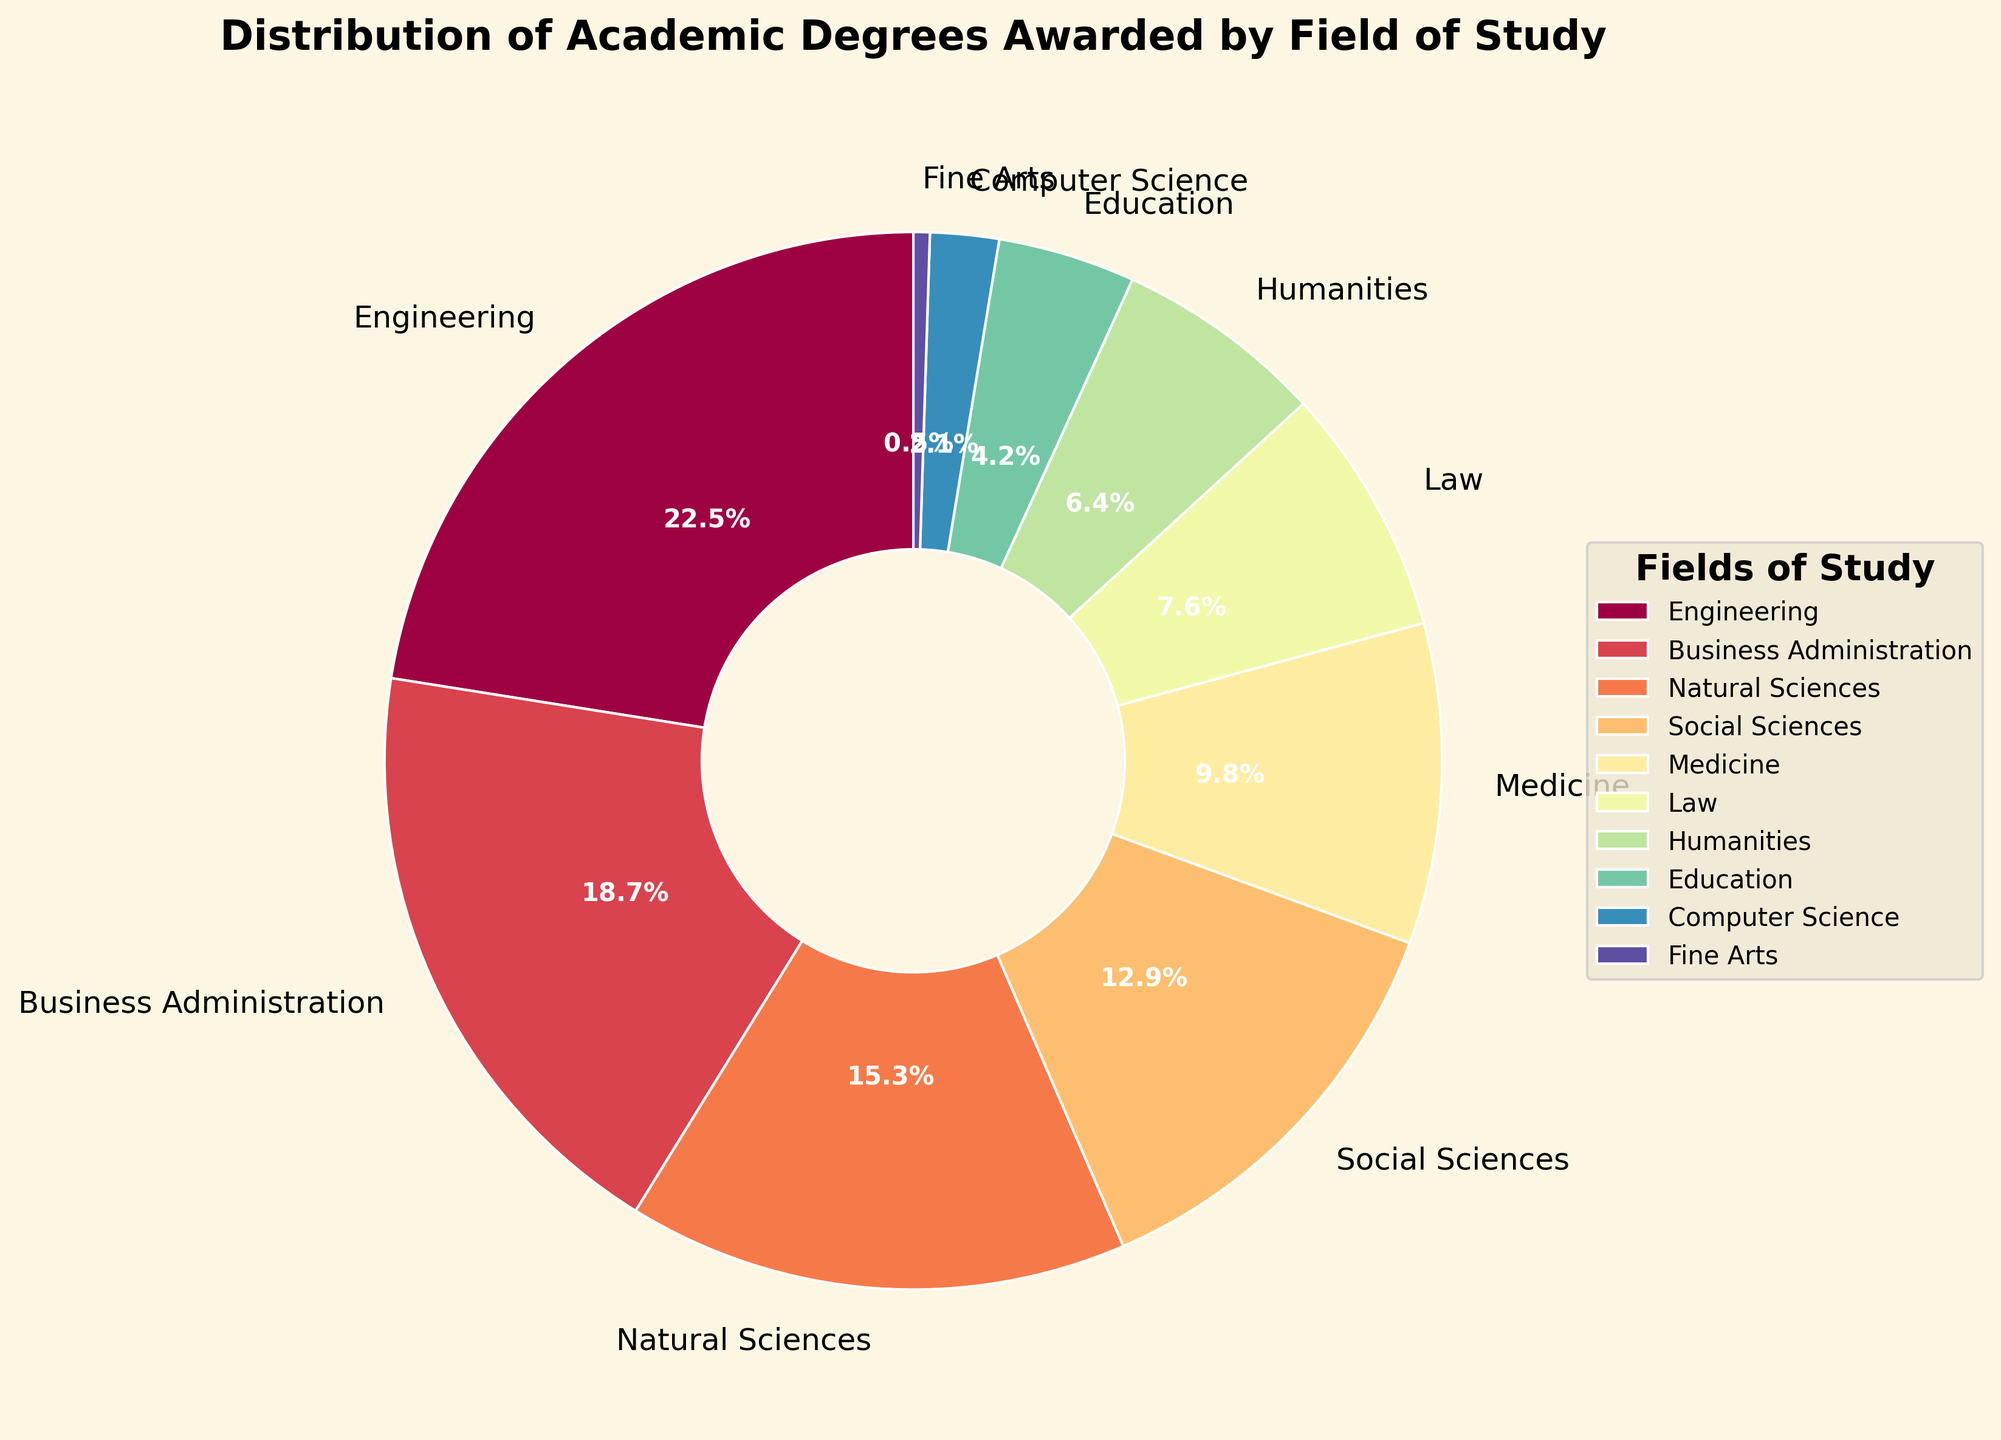Which field has the highest percentage of degrees awarded? By looking at the pie chart, the segment representing Engineering is the largest in size. The label on the Engineering segment indicates it has 22.5% of degrees awarded.
Answer: Engineering Compare the percentages of degrees awarded in Business Administration and Medicine. Which is higher, and by how much? The Business Administration segment is labeled with 18.7%, while the Medicine segment shows 9.8%. The difference is calculated as 18.7% - 9.8%.
Answer: Business Administration is higher by 8.9% What is the combined percentage of degrees awarded in Natural Sciences, Social Sciences, and Humanities? The percentages for Natural Sciences, Social Sciences, and Humanities are 15.3%, 12.9%, and 6.4%, respectively. Adding them together: 15.3% + 12.9% + 6.4%.
Answer: 34.6% Which fields have percentages below 5%, and what are their combined percentages? From the pie chart, the fields with percentages below 5% are Education (4.2%), Computer Science (2.1%), and Fine Arts (0.5%). Adding their percentages: 4.2% + 2.1% + 0.5%.
Answer: Education, Computer Science, Fine Arts with a combined percentage of 6.8% What is the ratio of degrees awarded in Law to those awarded in Fine Arts? The percentage for Law is 7.6% and for Fine Arts is 0.5%. The ratio is calculated as 7.6 / 0.5.
Answer: 15.2 Identify two fields whose combined percentage of degrees awarded is closest to the percentage for Engineering. The percentage for Engineering is 22.5%. The combined percentage closest to this is Social Sciences (12.9%) + Natural Sciences (15.3%). The pair Social Sciences and Natural Sciences has a combined percentage of 12.9% + 15.3%.
Answer: Social Sciences and Natural Sciences with a combined percentage of 28.2% How much higher is the percentage for Business Administration compared to Humanities? The percentage for Business Administration is 18.7%, and for Humanities, it is 6.4%. The difference is calculated as 18.7% - 6.4%.
Answer: 12.3% Estimate the percentage of degrees awarded in non-STEM fields (all fields except Engineering, Natural Sciences, and Computer Science). The percentages for non-STEM fields are Business Administration (18.7%), Social Sciences (12.9%), Medicine (9.8%), Law (7.6%), Humanities (6.4%), Education (4.2%), and Fine Arts (0.5%). Adding these together: 18.7% + 12.9% + 9.8% + 7.6% + 6.4% + 4.2% + 0.5%.
Answer: 60.1% Which field's segment in the pie chart uses the most intense color shade, assuming Spectral colormap? Spectral colormap makes the color transition from one end of the spectrum to the other. The Engineering segment, having the highest percentage, should be the most intense or darkest in the colormap range used.
Answer: Engineering 